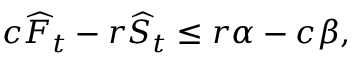Convert formula to latex. <formula><loc_0><loc_0><loc_500><loc_500>c \widehat { F } _ { t } - r \widehat { S } _ { t } \leq r \alpha - c \beta ,</formula> 